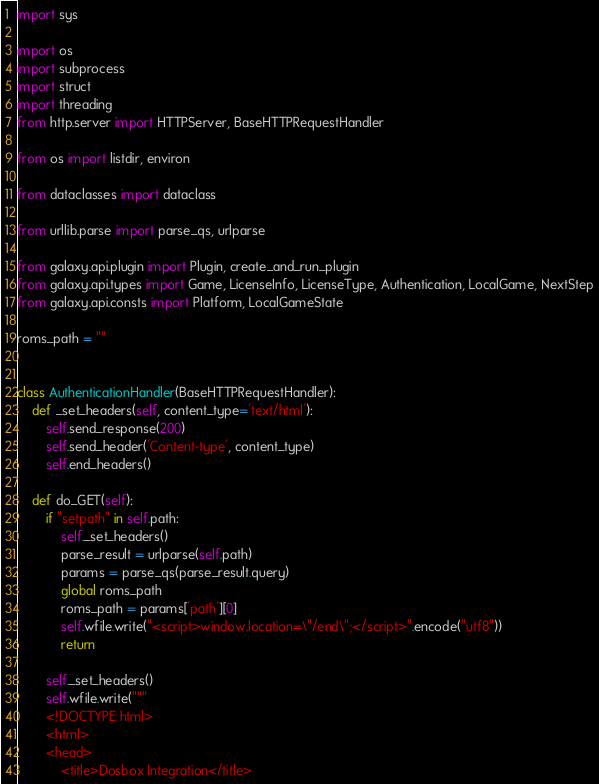<code> <loc_0><loc_0><loc_500><loc_500><_Python_>import sys

import os
import subprocess
import struct
import threading
from http.server import HTTPServer, BaseHTTPRequestHandler

from os import listdir, environ

from dataclasses import dataclass

from urllib.parse import parse_qs, urlparse

from galaxy.api.plugin import Plugin, create_and_run_plugin
from galaxy.api.types import Game, LicenseInfo, LicenseType, Authentication, LocalGame, NextStep
from galaxy.api.consts import Platform, LocalGameState

roms_path = ""


class AuthenticationHandler(BaseHTTPRequestHandler):
    def _set_headers(self, content_type='text/html'):
        self.send_response(200)
        self.send_header('Content-type', content_type)
        self.end_headers()

    def do_GET(self):
        if "setpath" in self.path:
            self._set_headers()
            parse_result = urlparse(self.path)
            params = parse_qs(parse_result.query)
            global roms_path
            roms_path = params['path'][0]
            self.wfile.write("<script>window.location=\"/end\";</script>".encode("utf8"))
            return

        self._set_headers()
        self.wfile.write("""
        <!DOCTYPE html>
        <html>
        <head>
            <title>Dosbox Integration</title></code> 